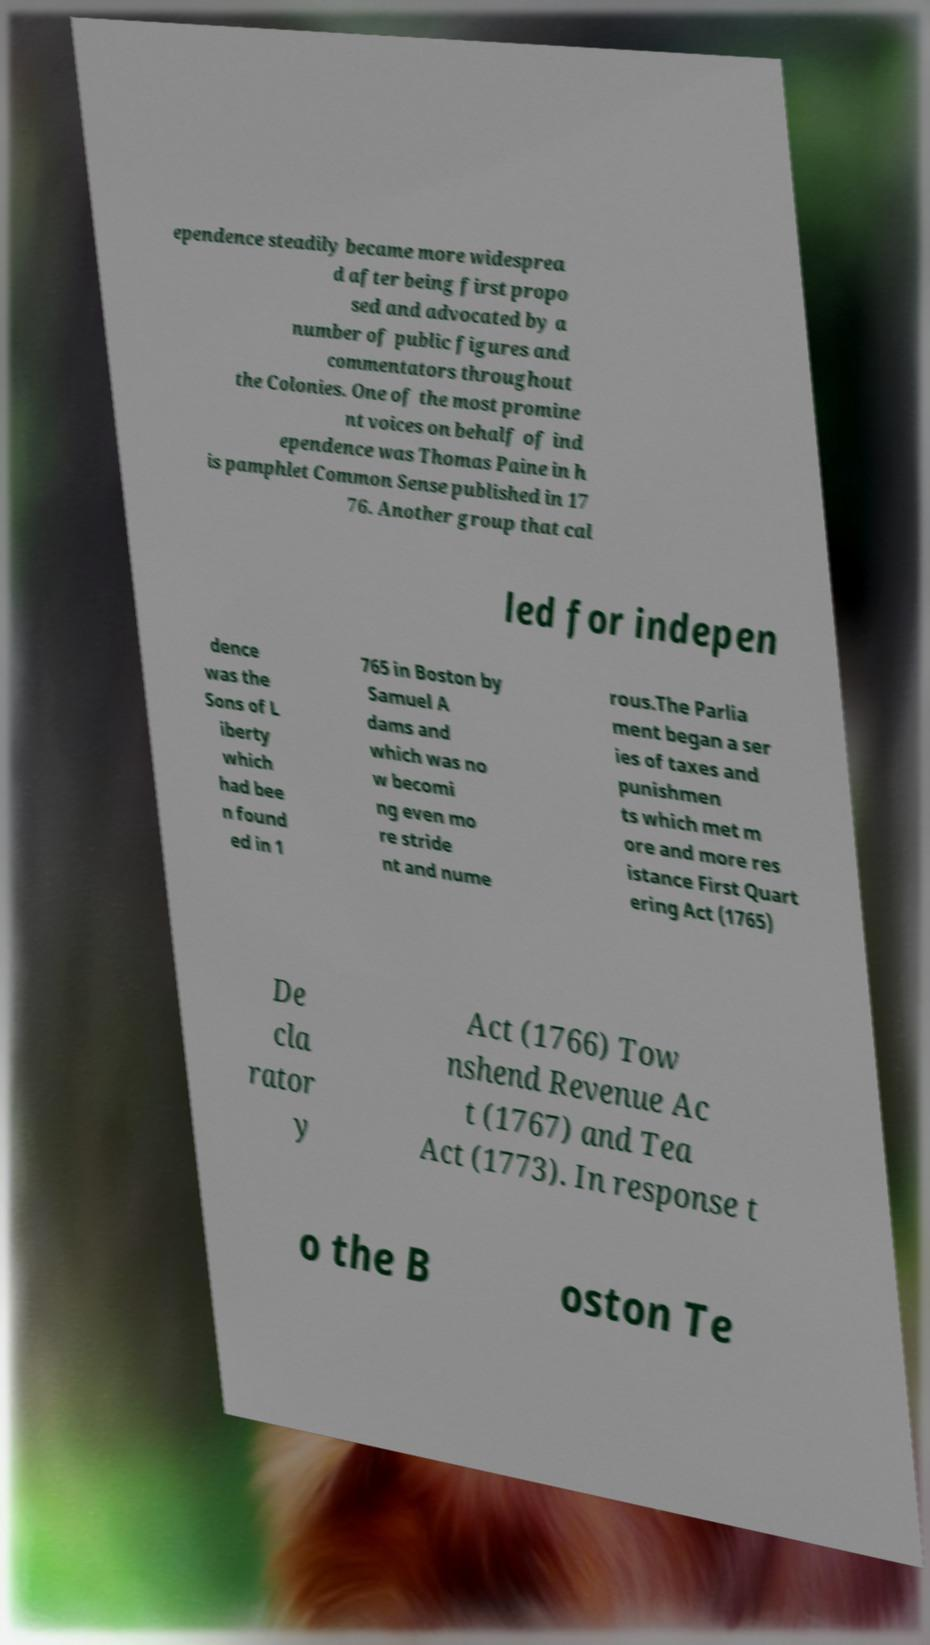Could you assist in decoding the text presented in this image and type it out clearly? ependence steadily became more widesprea d after being first propo sed and advocated by a number of public figures and commentators throughout the Colonies. One of the most promine nt voices on behalf of ind ependence was Thomas Paine in h is pamphlet Common Sense published in 17 76. Another group that cal led for indepen dence was the Sons of L iberty which had bee n found ed in 1 765 in Boston by Samuel A dams and which was no w becomi ng even mo re stride nt and nume rous.The Parlia ment began a ser ies of taxes and punishmen ts which met m ore and more res istance First Quart ering Act (1765) De cla rator y Act (1766) Tow nshend Revenue Ac t (1767) and Tea Act (1773). In response t o the B oston Te 